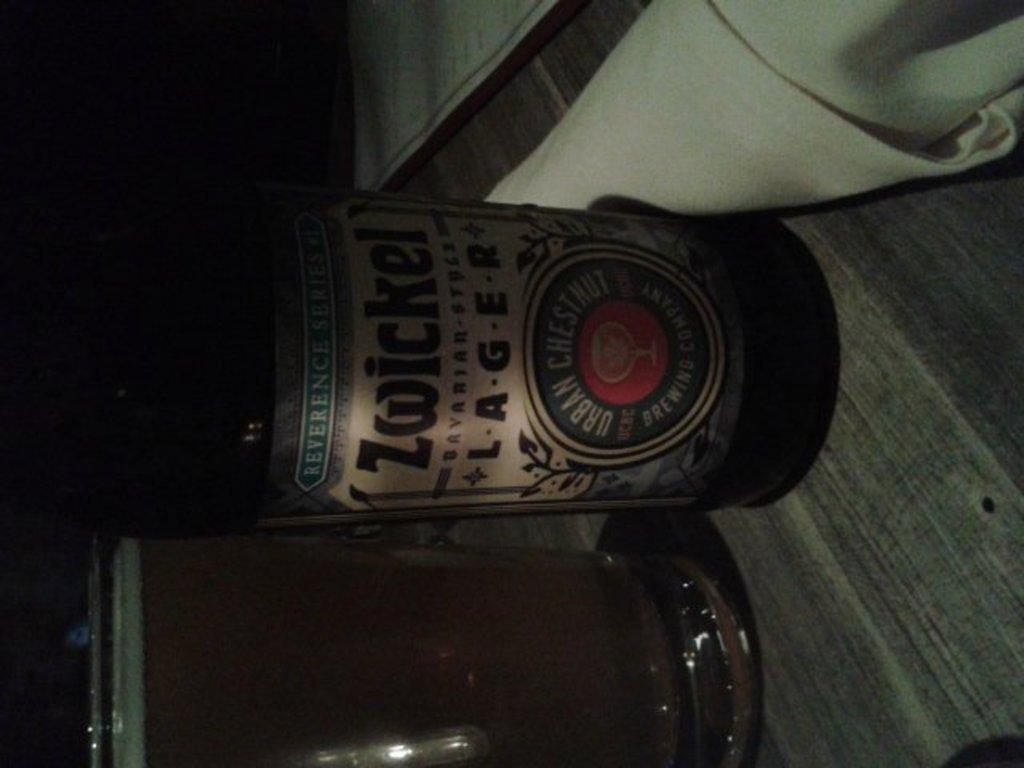<image>
Write a terse but informative summary of the picture. a beer bottle with the word chestnut on it 